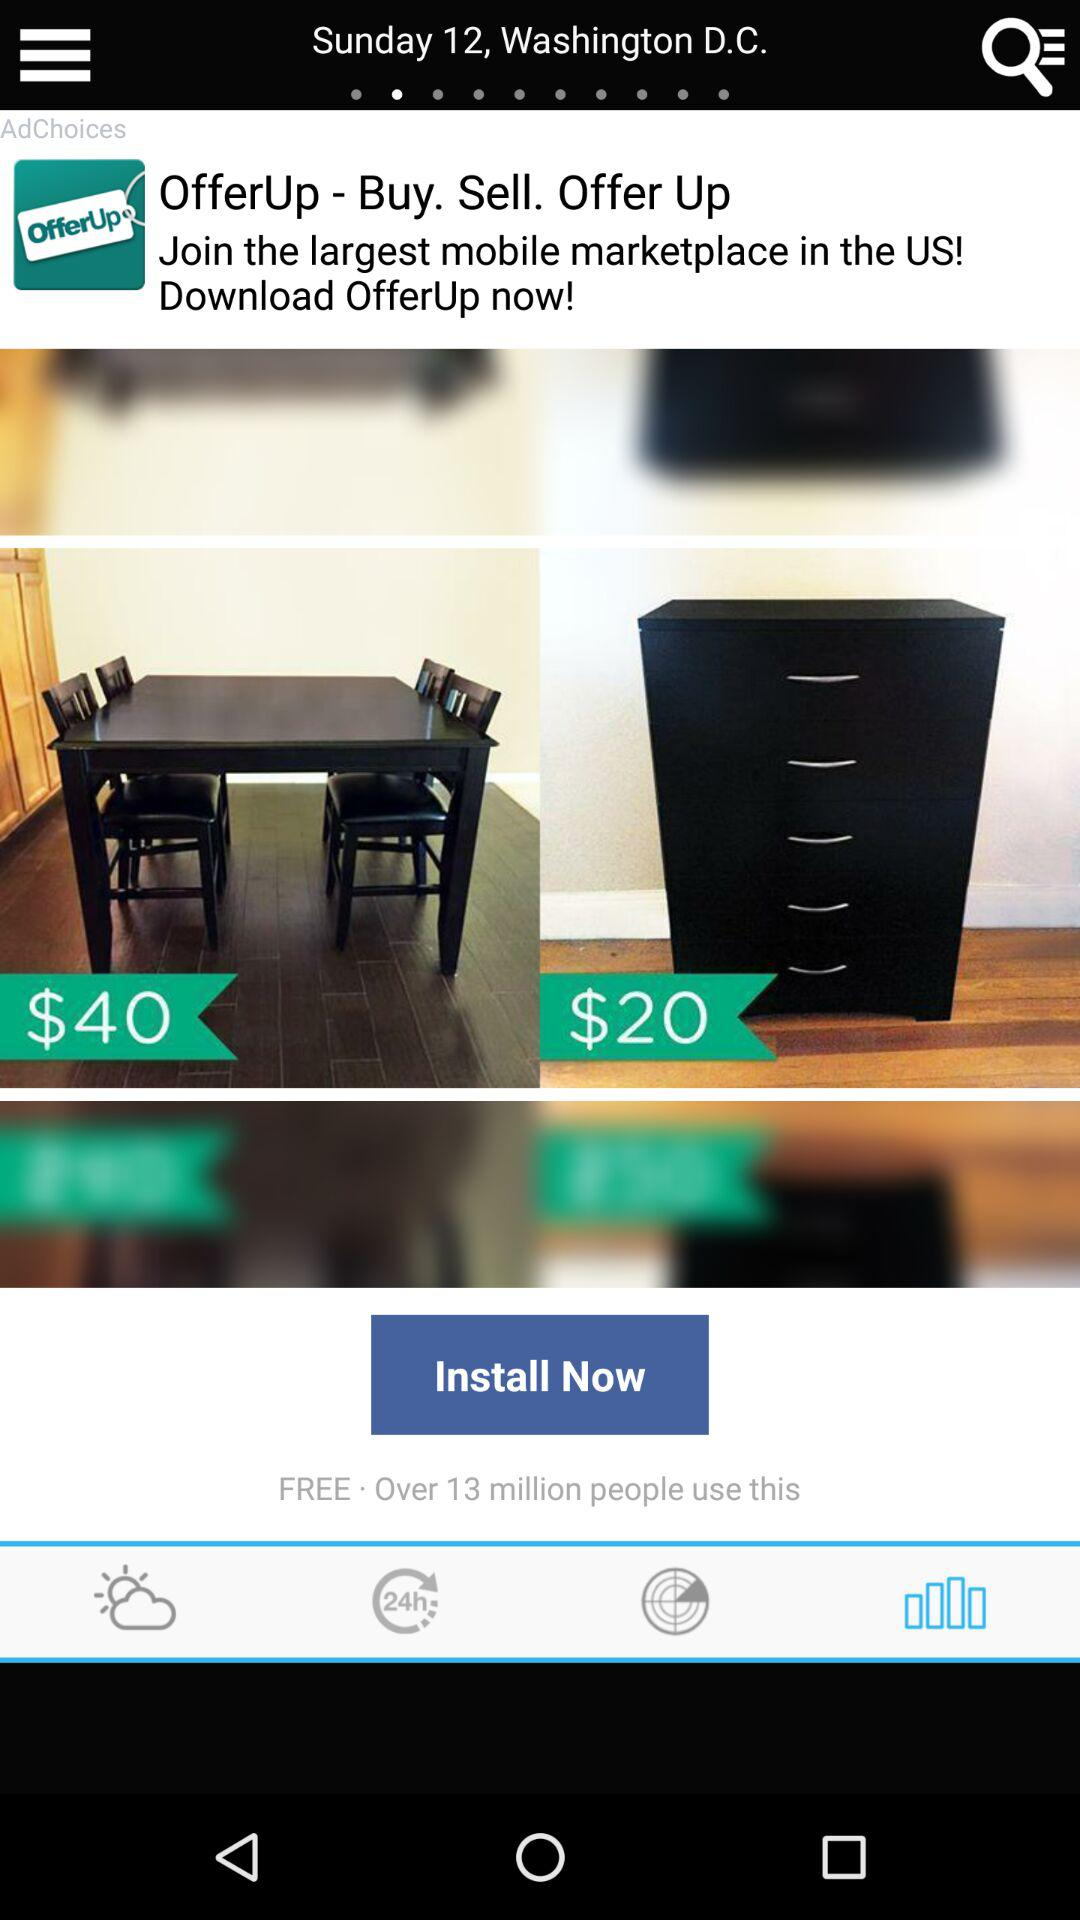What is the day on the shown date? The day on the shown date is Sunday. 